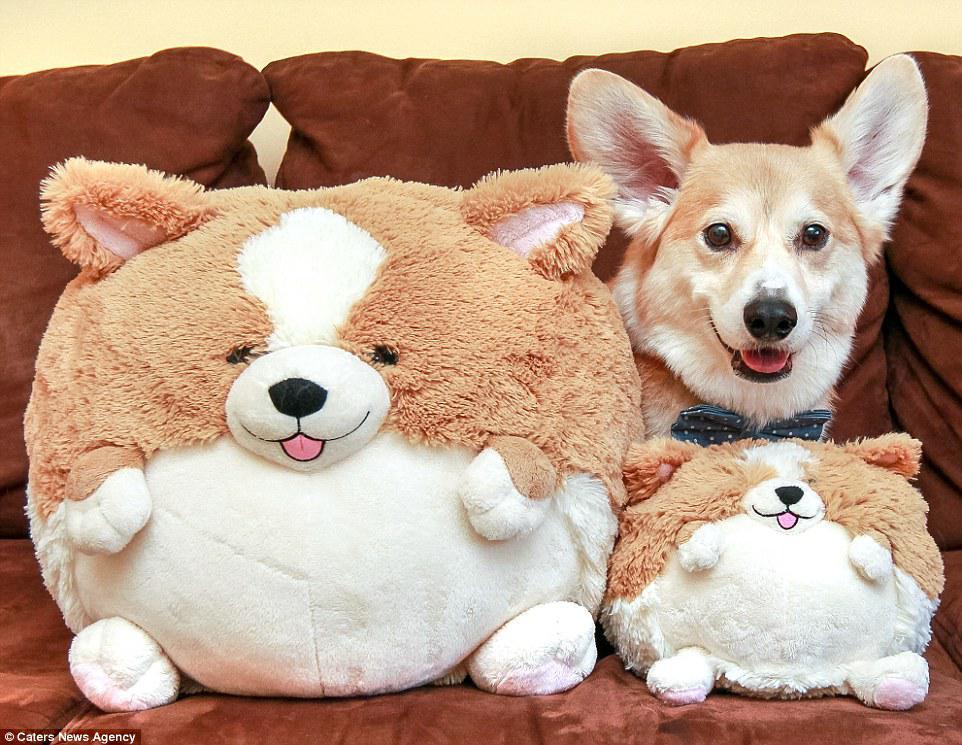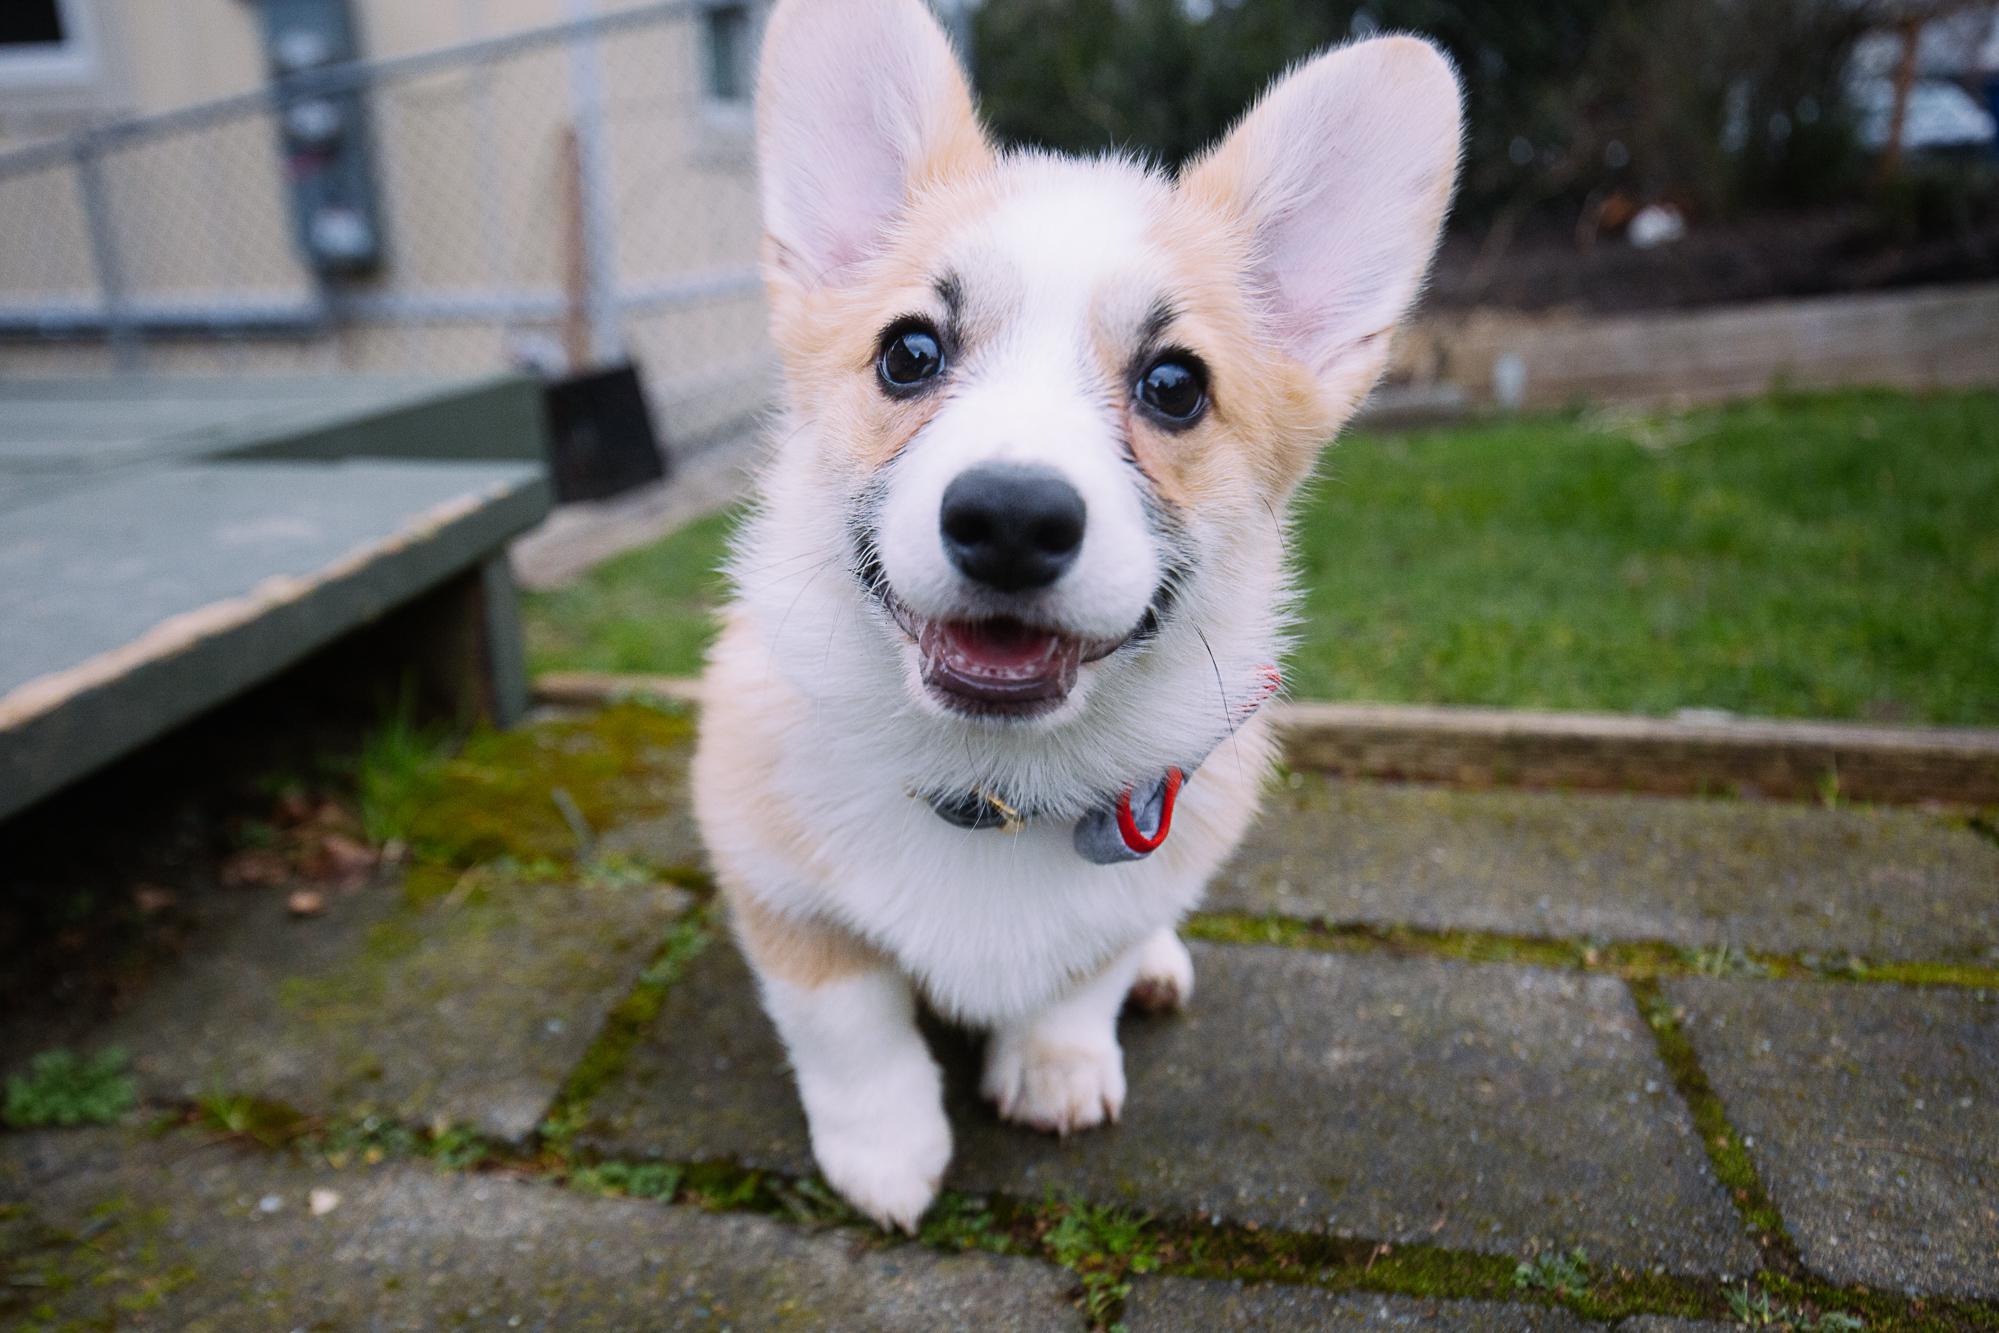The first image is the image on the left, the second image is the image on the right. Evaluate the accuracy of this statement regarding the images: "The left image features one live dog posed with at least one stuffed animal figure, and the right image shows one dog that is not wearing any human-type attire.". Is it true? Answer yes or no. Yes. 